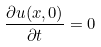Convert formula to latex. <formula><loc_0><loc_0><loc_500><loc_500>\frac { \partial u ( x , 0 ) } { \partial t } = 0</formula> 